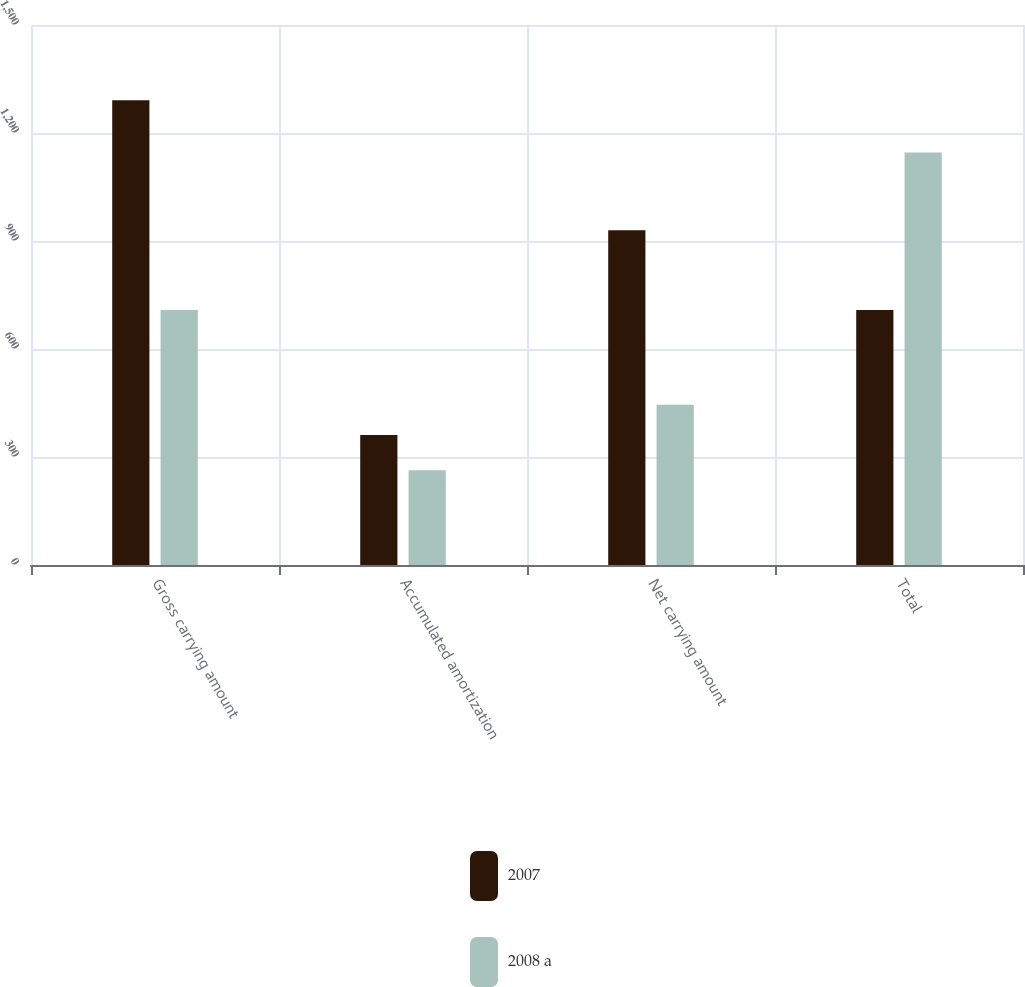Convert chart to OTSL. <chart><loc_0><loc_0><loc_500><loc_500><stacked_bar_chart><ecel><fcel>Gross carrying amount<fcel>Accumulated amortization<fcel>Net carrying amount<fcel>Total<nl><fcel>2007<fcel>1291<fcel>361<fcel>930<fcel>708<nl><fcel>2008 a<fcel>708<fcel>263<fcel>445<fcel>1146<nl></chart> 